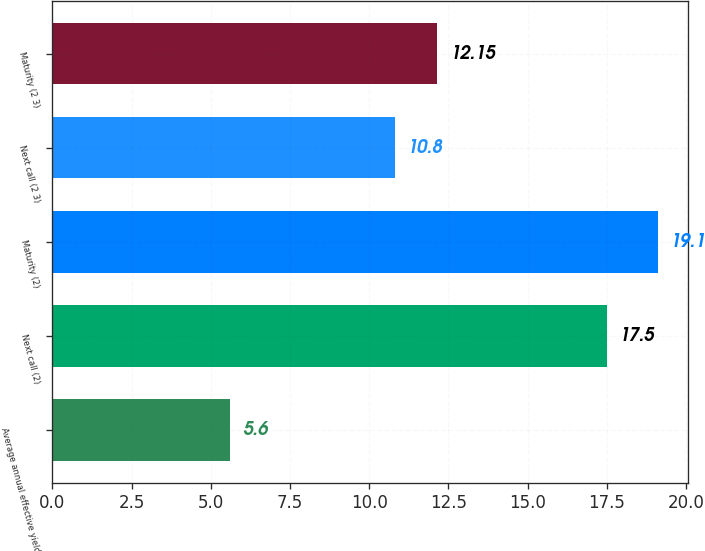<chart> <loc_0><loc_0><loc_500><loc_500><bar_chart><fcel>Average annual effective yield<fcel>Next call (2)<fcel>Maturity (2)<fcel>Next call (2 3)<fcel>Maturity (2 3)<nl><fcel>5.6<fcel>17.5<fcel>19.1<fcel>10.8<fcel>12.15<nl></chart> 